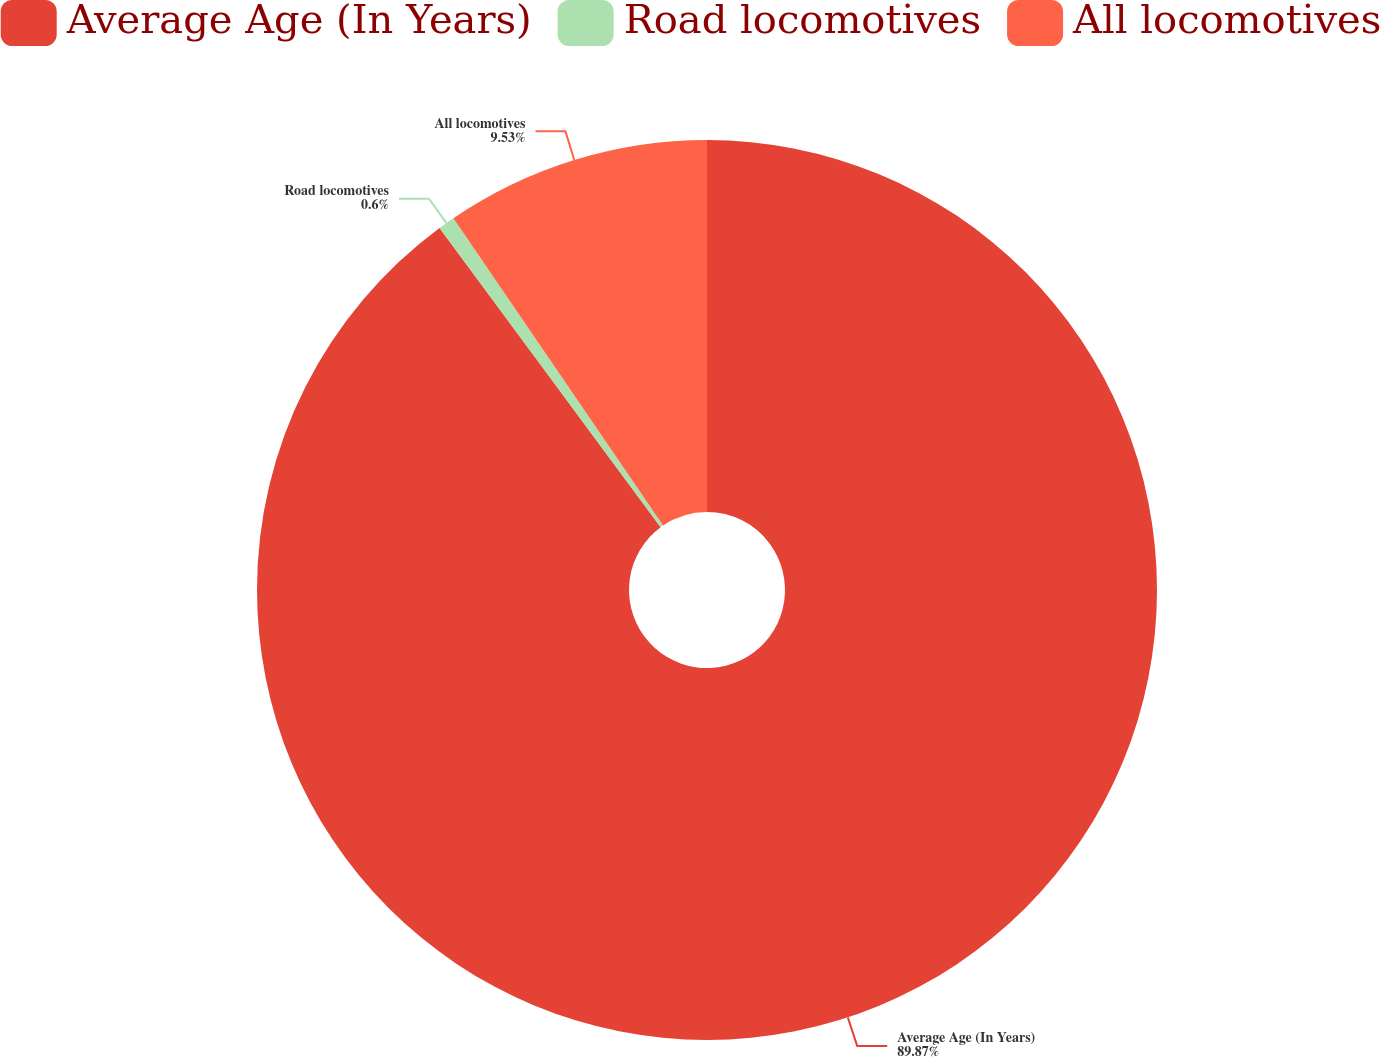Convert chart to OTSL. <chart><loc_0><loc_0><loc_500><loc_500><pie_chart><fcel>Average Age (In Years)<fcel>Road locomotives<fcel>All locomotives<nl><fcel>89.87%<fcel>0.6%<fcel>9.53%<nl></chart> 